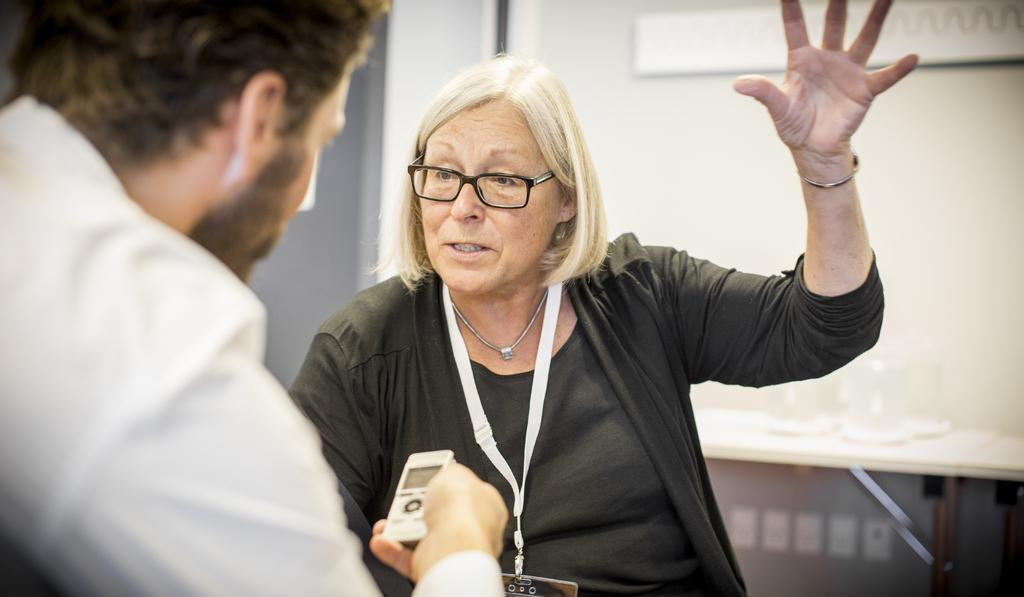How many people are in the image? There are two persons in the image. What is one person doing in the image? One person is holding an object. Can you describe the other person in the image? The other person is wearing an identity card. What is visible behind one of the persons? There is an object behind one of the persons. What type of wind can be seen blowing through the bushes in the image? There are no bushes or wind present in the image. How many passengers are visible in the image? There is no reference to passengers in the image, as it only features two persons. 